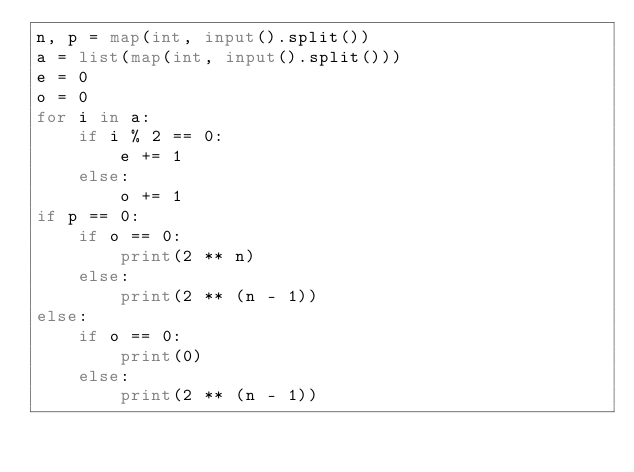Convert code to text. <code><loc_0><loc_0><loc_500><loc_500><_Python_>n, p = map(int, input().split())
a = list(map(int, input().split()))
e = 0
o = 0
for i in a:
    if i % 2 == 0:
        e += 1
    else:
        o += 1
if p == 0:
    if o == 0:
        print(2 ** n)
    else:
        print(2 ** (n - 1))
else:
    if o == 0:
        print(0)
    else:
        print(2 ** (n - 1))

</code> 